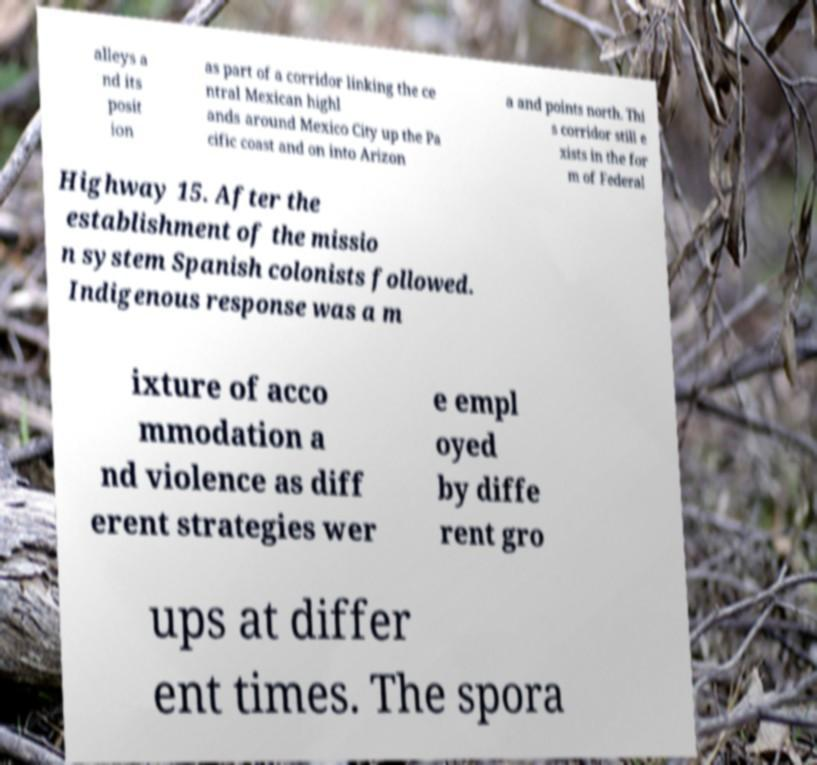Can you accurately transcribe the text from the provided image for me? alleys a nd its posit ion as part of a corridor linking the ce ntral Mexican highl ands around Mexico City up the Pa cific coast and on into Arizon a and points north. Thi s corridor still e xists in the for m of Federal Highway 15. After the establishment of the missio n system Spanish colonists followed. Indigenous response was a m ixture of acco mmodation a nd violence as diff erent strategies wer e empl oyed by diffe rent gro ups at differ ent times. The spora 